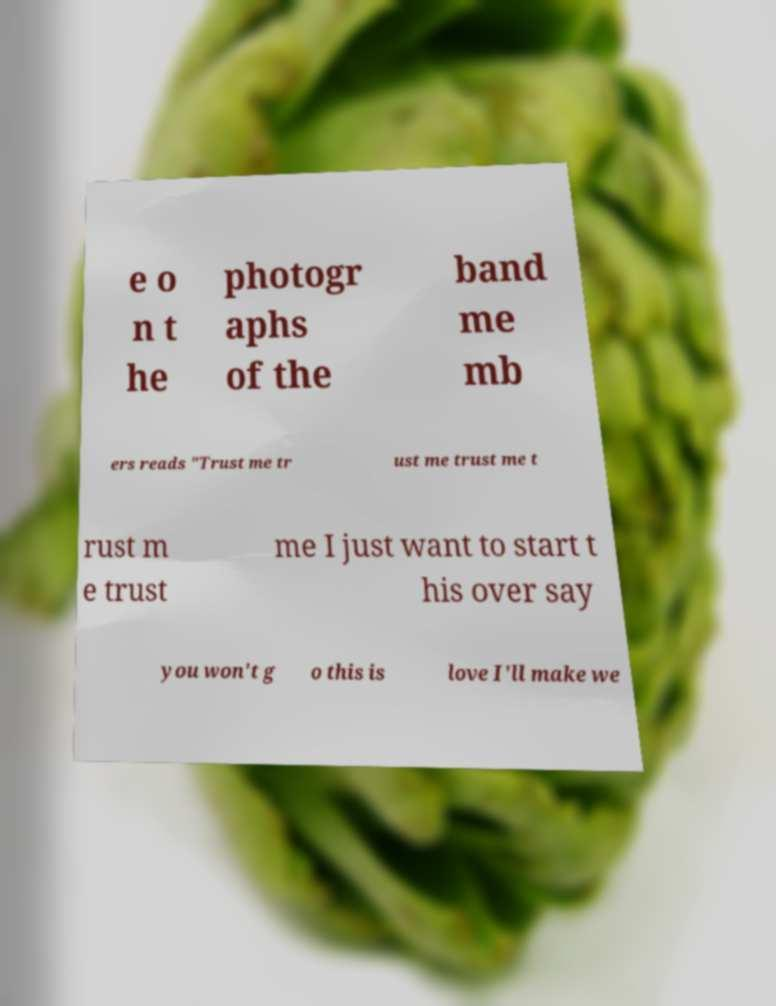Could you assist in decoding the text presented in this image and type it out clearly? e o n t he photogr aphs of the band me mb ers reads "Trust me tr ust me trust me t rust m e trust me I just want to start t his over say you won't g o this is love I'll make we 